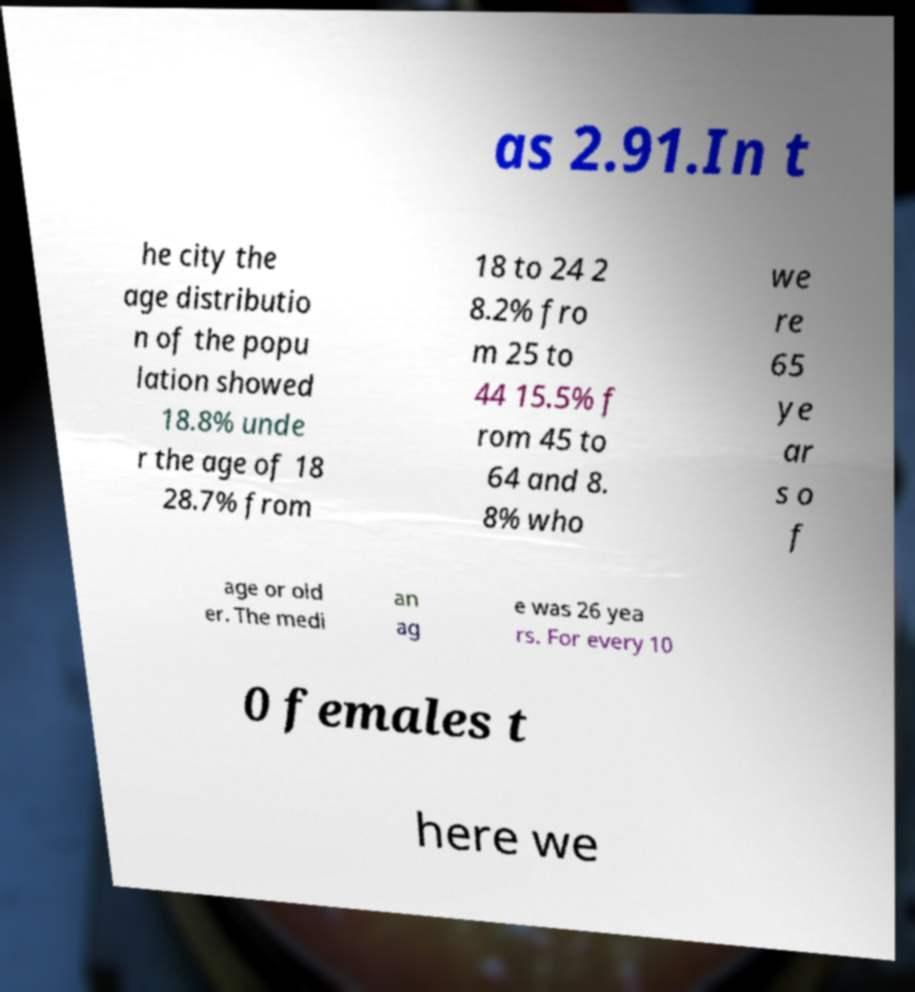For documentation purposes, I need the text within this image transcribed. Could you provide that? as 2.91.In t he city the age distributio n of the popu lation showed 18.8% unde r the age of 18 28.7% from 18 to 24 2 8.2% fro m 25 to 44 15.5% f rom 45 to 64 and 8. 8% who we re 65 ye ar s o f age or old er. The medi an ag e was 26 yea rs. For every 10 0 females t here we 